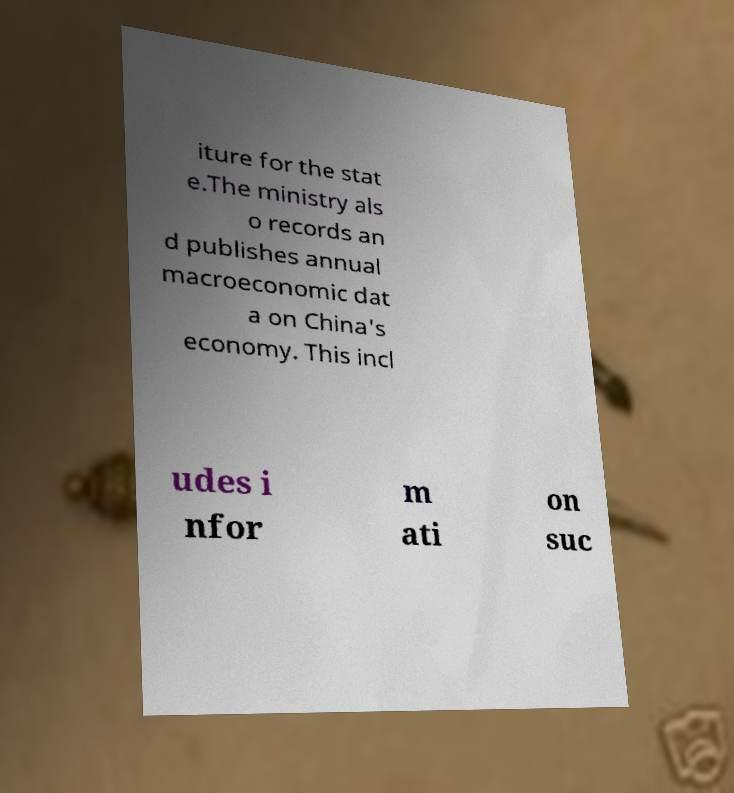Could you extract and type out the text from this image? iture for the stat e.The ministry als o records an d publishes annual macroeconomic dat a on China's economy. This incl udes i nfor m ati on suc 